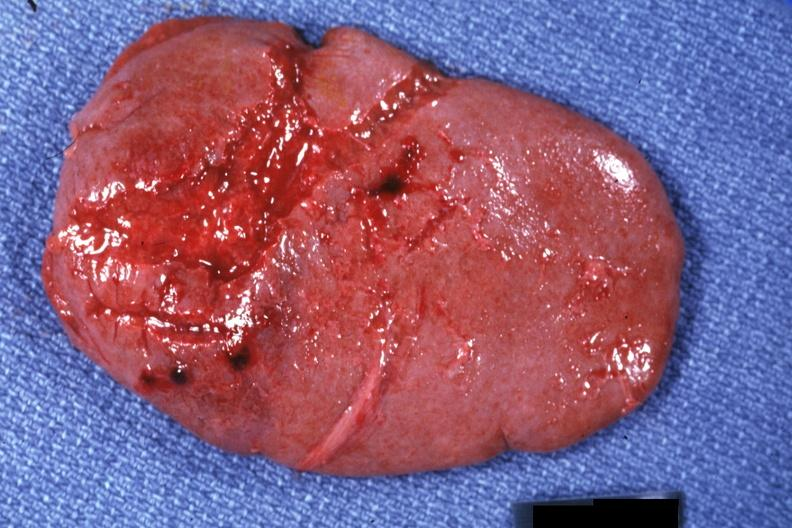s side present?
Answer the question using a single word or phrase. No 